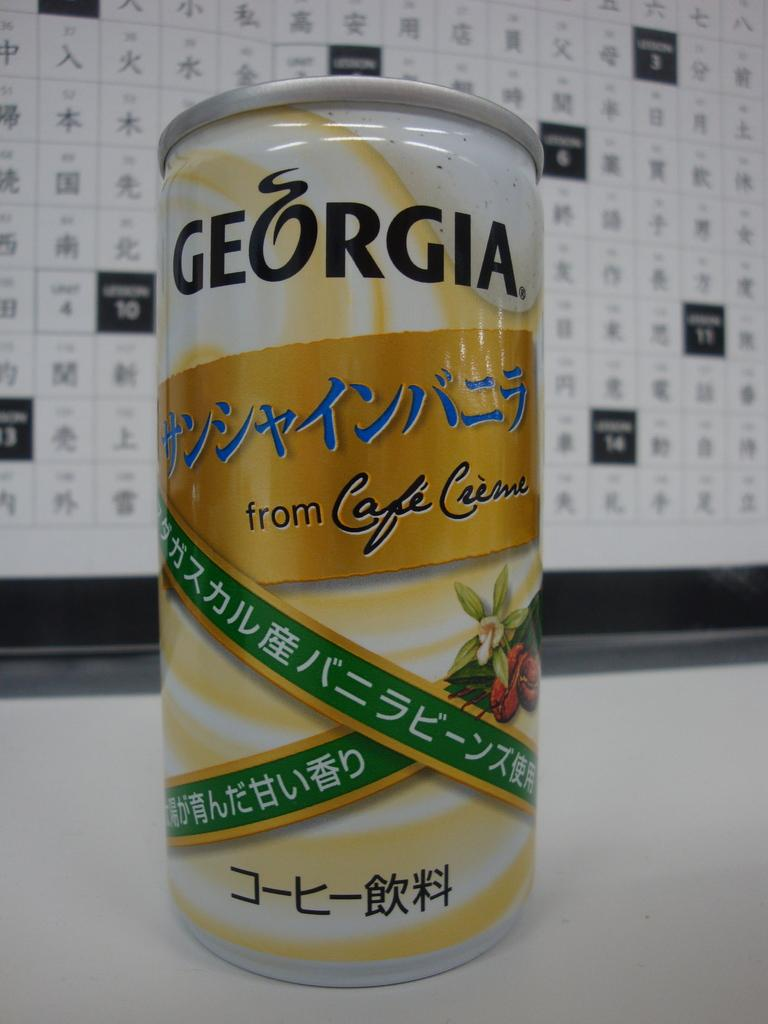<image>
Create a compact narrative representing the image presented. A can with Chinese writing on it, also labeled GEORGIA from Cafe Creme. 